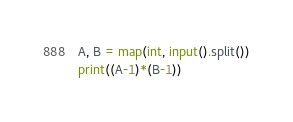<code> <loc_0><loc_0><loc_500><loc_500><_Python_>A, B = map(int, input().split())
print((A-1)*(B-1))</code> 